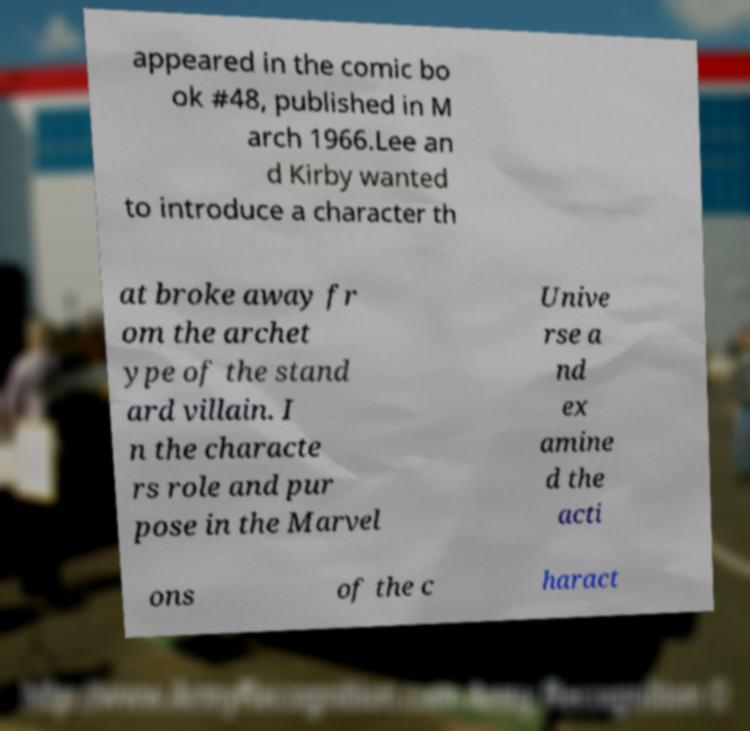Could you extract and type out the text from this image? appeared in the comic bo ok #48, published in M arch 1966.Lee an d Kirby wanted to introduce a character th at broke away fr om the archet ype of the stand ard villain. I n the characte rs role and pur pose in the Marvel Unive rse a nd ex amine d the acti ons of the c haract 